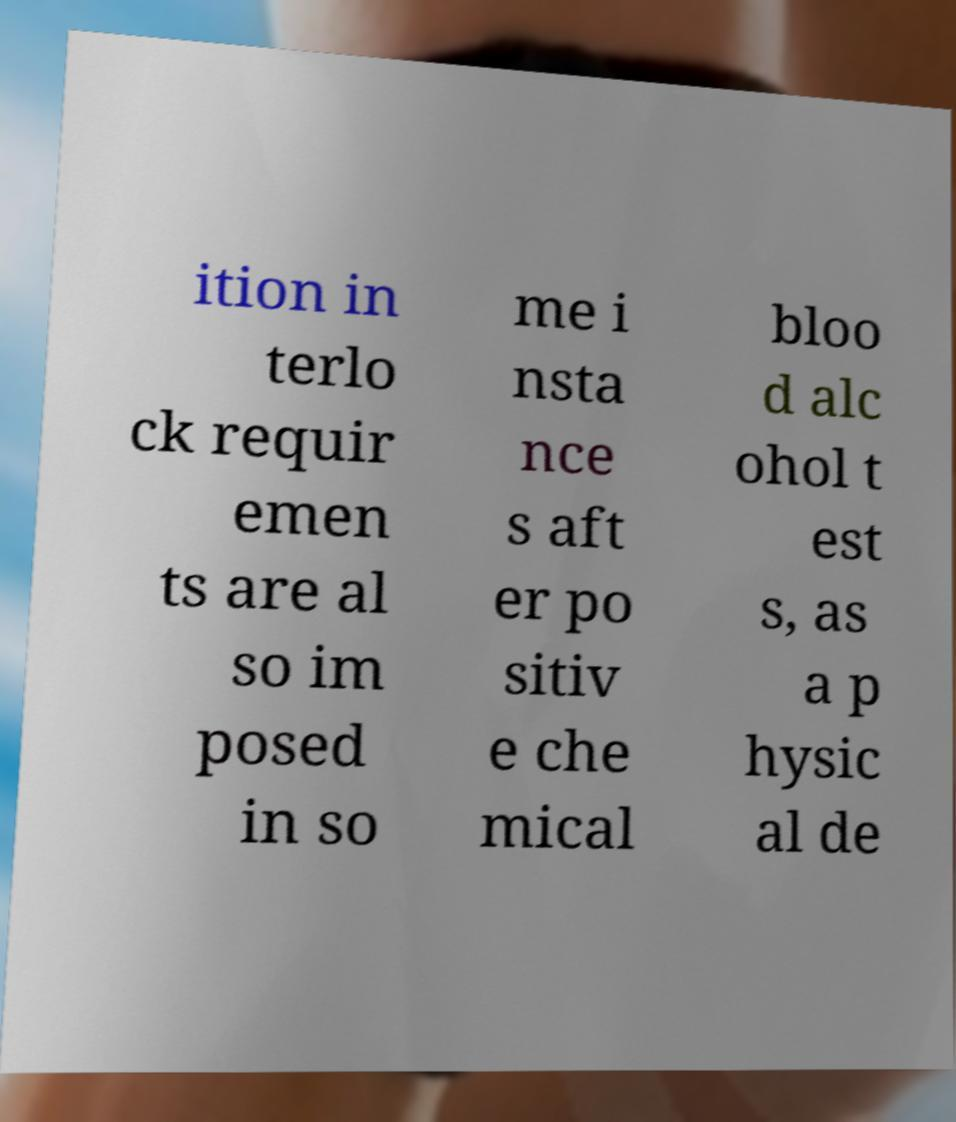Can you accurately transcribe the text from the provided image for me? ition in terlo ck requir emen ts are al so im posed in so me i nsta nce s aft er po sitiv e che mical bloo d alc ohol t est s, as a p hysic al de 